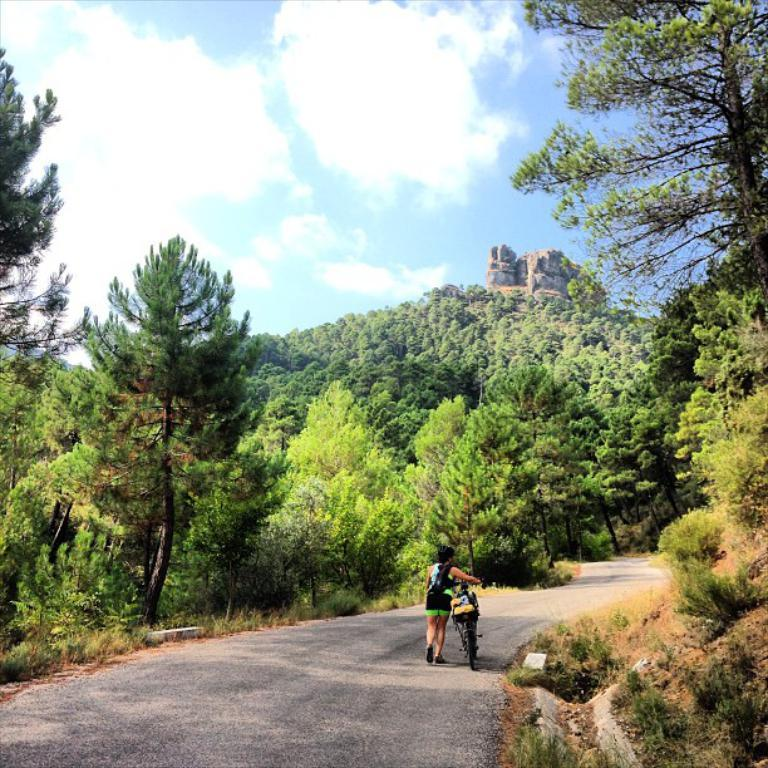What is the main subject of the image? There is a person in the image. What is the person holding in the image? The person is holding a bicycle. What can be seen in the background of the image? There are trees and the sky visible in the background of the image. What is the color of the trees in the image? The trees are green. What is the color of the sky in the image? The sky is blue and white. What word is the person saying to their dad in the image? There is no indication in the image that the person is saying anything to their dad, as there is no dad present in the image. What verse is the person reciting in the image? There is no indication in the image that the person is reciting a verse, as there is no mention of any recitation or verse in the provided facts. 